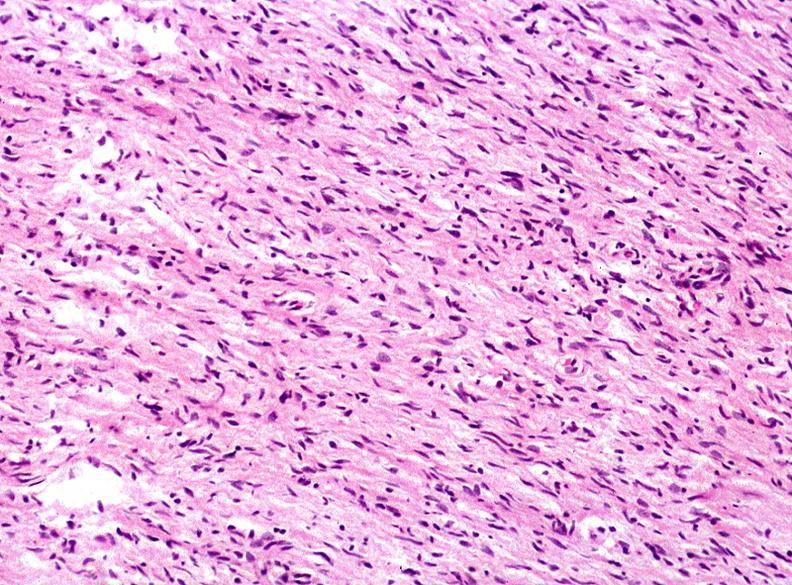where is this?
Answer the question using a single word or phrase. Skin 